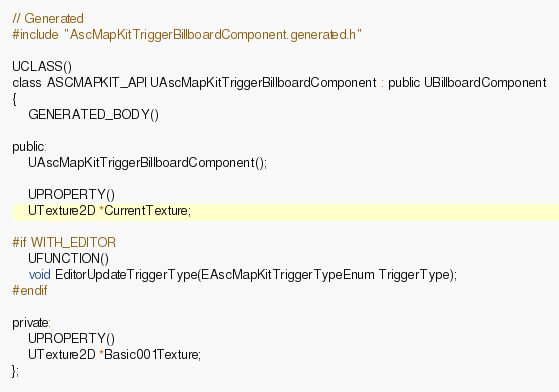Convert code to text. <code><loc_0><loc_0><loc_500><loc_500><_C_>
// Generated
#include "AscMapKitTriggerBillboardComponent.generated.h"

UCLASS()
class ASCMAPKIT_API UAscMapKitTriggerBillboardComponent : public UBillboardComponent
{
    GENERATED_BODY()

public:
    UAscMapKitTriggerBillboardComponent();

    UPROPERTY()
    UTexture2D *CurrentTexture;

#if WITH_EDITOR
    UFUNCTION()
    void EditorUpdateTriggerType(EAscMapKitTriggerTypeEnum TriggerType);
#endif

private:
    UPROPERTY()
    UTexture2D *Basic001Texture;
};</code> 